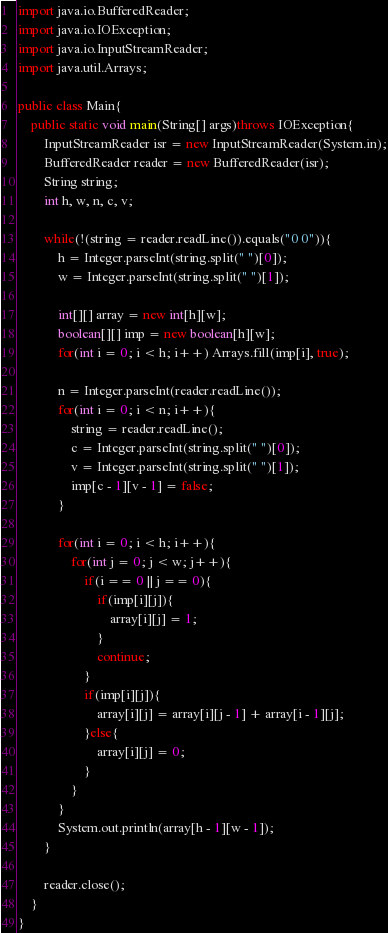Convert code to text. <code><loc_0><loc_0><loc_500><loc_500><_Java_>import java.io.BufferedReader;
import java.io.IOException;
import java.io.InputStreamReader;
import java.util.Arrays;

public class Main{
	public static void main(String[] args)throws IOException{
		InputStreamReader isr = new InputStreamReader(System.in);
		BufferedReader reader = new BufferedReader(isr);
		String string;
		int h, w, n, c, v;
		
		while(!(string = reader.readLine()).equals("0 0")){
			h = Integer.parseInt(string.split(" ")[0]);
			w = Integer.parseInt(string.split(" ")[1]);
			
			int[][] array = new int[h][w];
			boolean[][] imp = new boolean[h][w];
			for(int i = 0; i < h; i++) Arrays.fill(imp[i], true);
			
			n = Integer.parseInt(reader.readLine());
			for(int i = 0; i < n; i++){
				string = reader.readLine();
				c = Integer.parseInt(string.split(" ")[0]);
				v = Integer.parseInt(string.split(" ")[1]);
				imp[c - 1][v - 1] = false;
			}
			
			for(int i = 0; i < h; i++){
				for(int j = 0; j < w; j++){
					if(i == 0 || j == 0){
						if(imp[i][j]){
							array[i][j] = 1;
						}
						continue;
					}
					if(imp[i][j]){
						array[i][j] = array[i][j - 1] + array[i - 1][j];
					}else{
						array[i][j] = 0;
					}
				}
			}
			System.out.println(array[h - 1][w - 1]);
		}
		
		reader.close();
	}
}</code> 